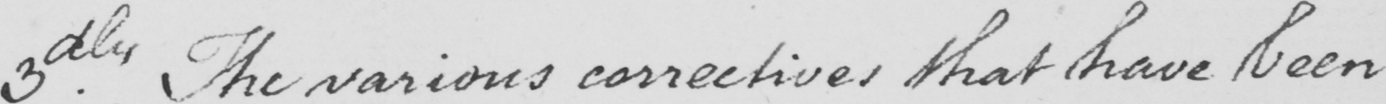Can you read and transcribe this handwriting? 3dly . The various correctives that have been 